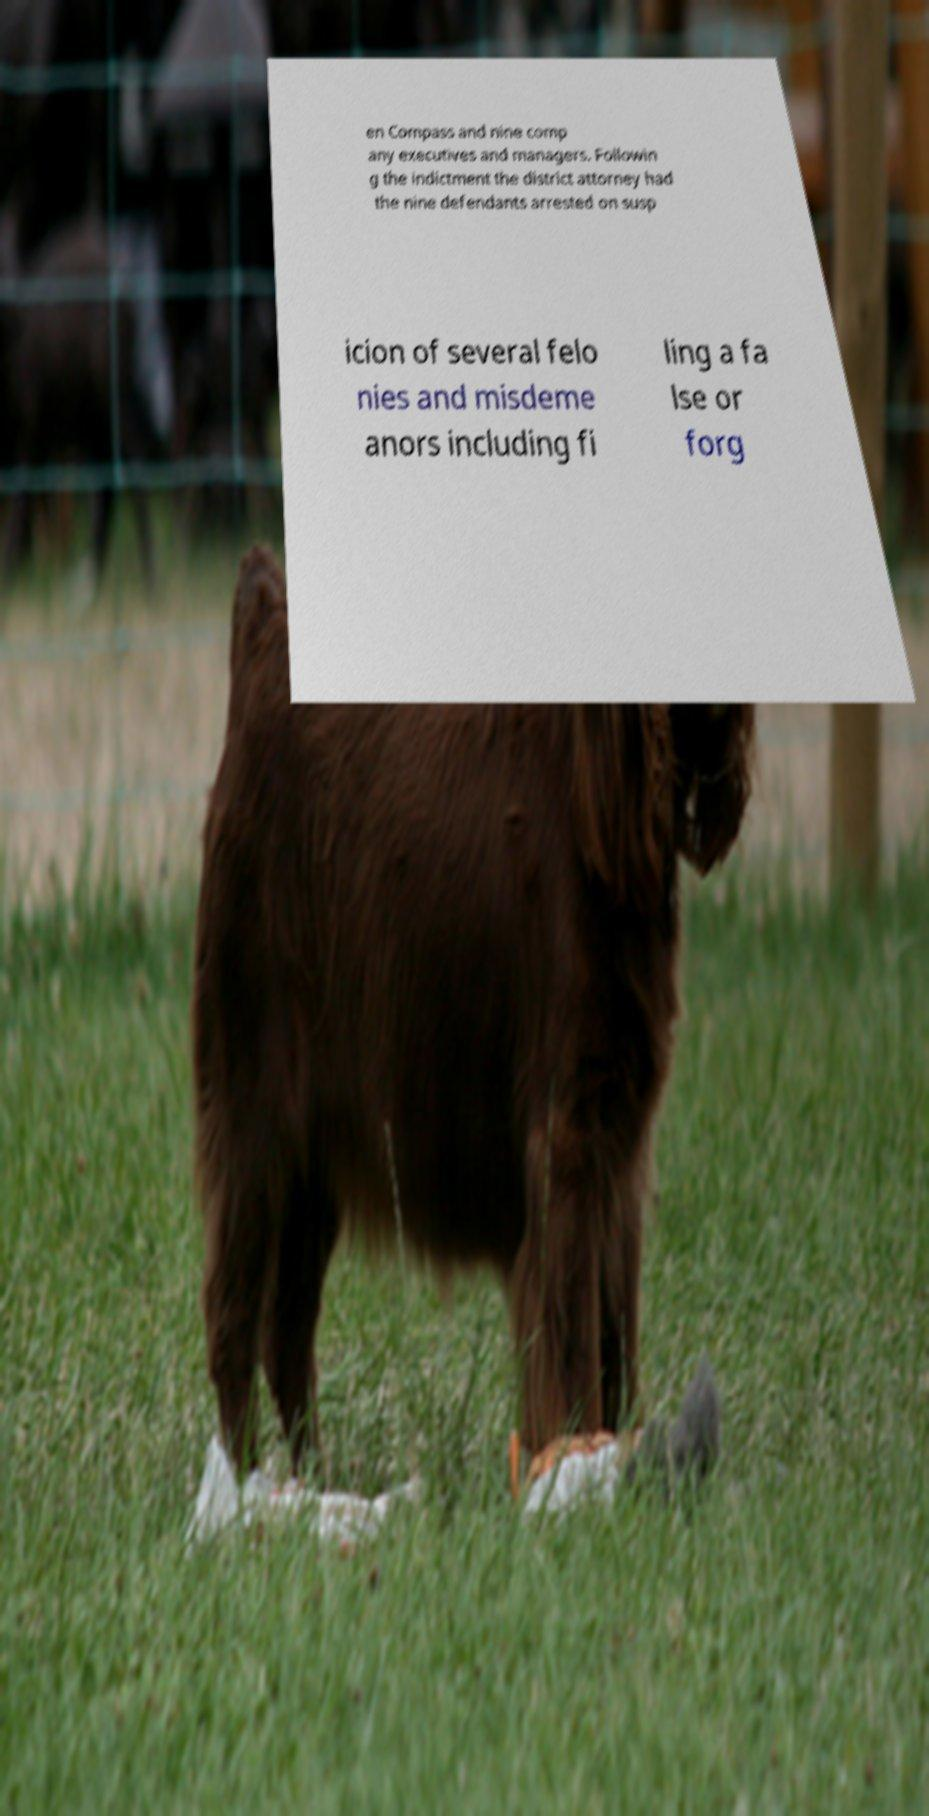For documentation purposes, I need the text within this image transcribed. Could you provide that? en Compass and nine comp any executives and managers. Followin g the indictment the district attorney had the nine defendants arrested on susp icion of several felo nies and misdeme anors including fi ling a fa lse or forg 